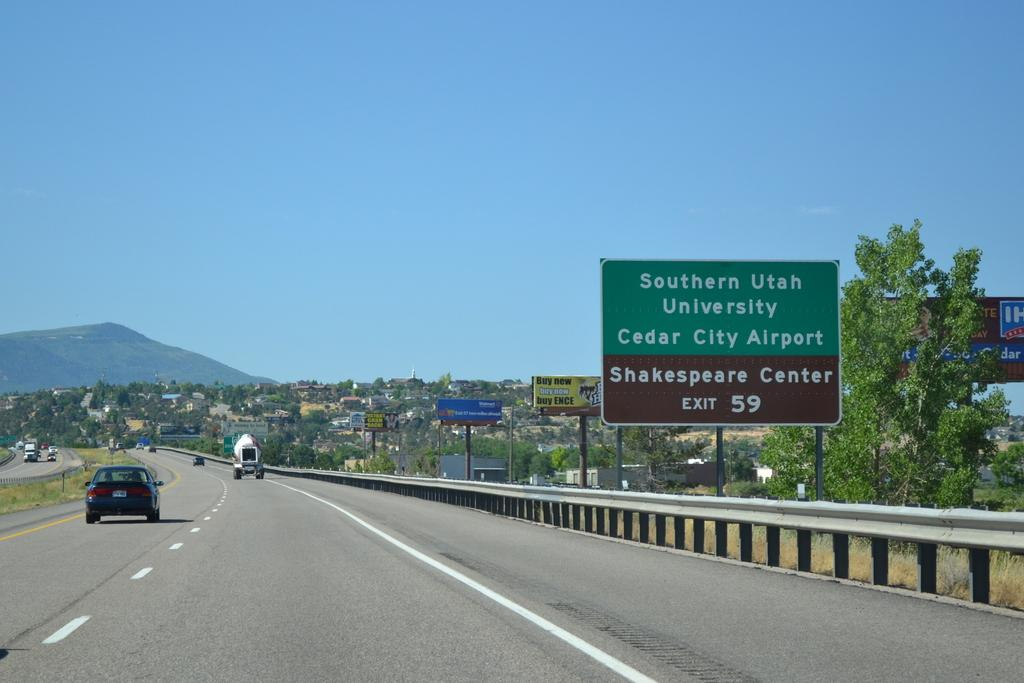<image>
Describe the image concisely. many signs on highway with one that says southern utah 